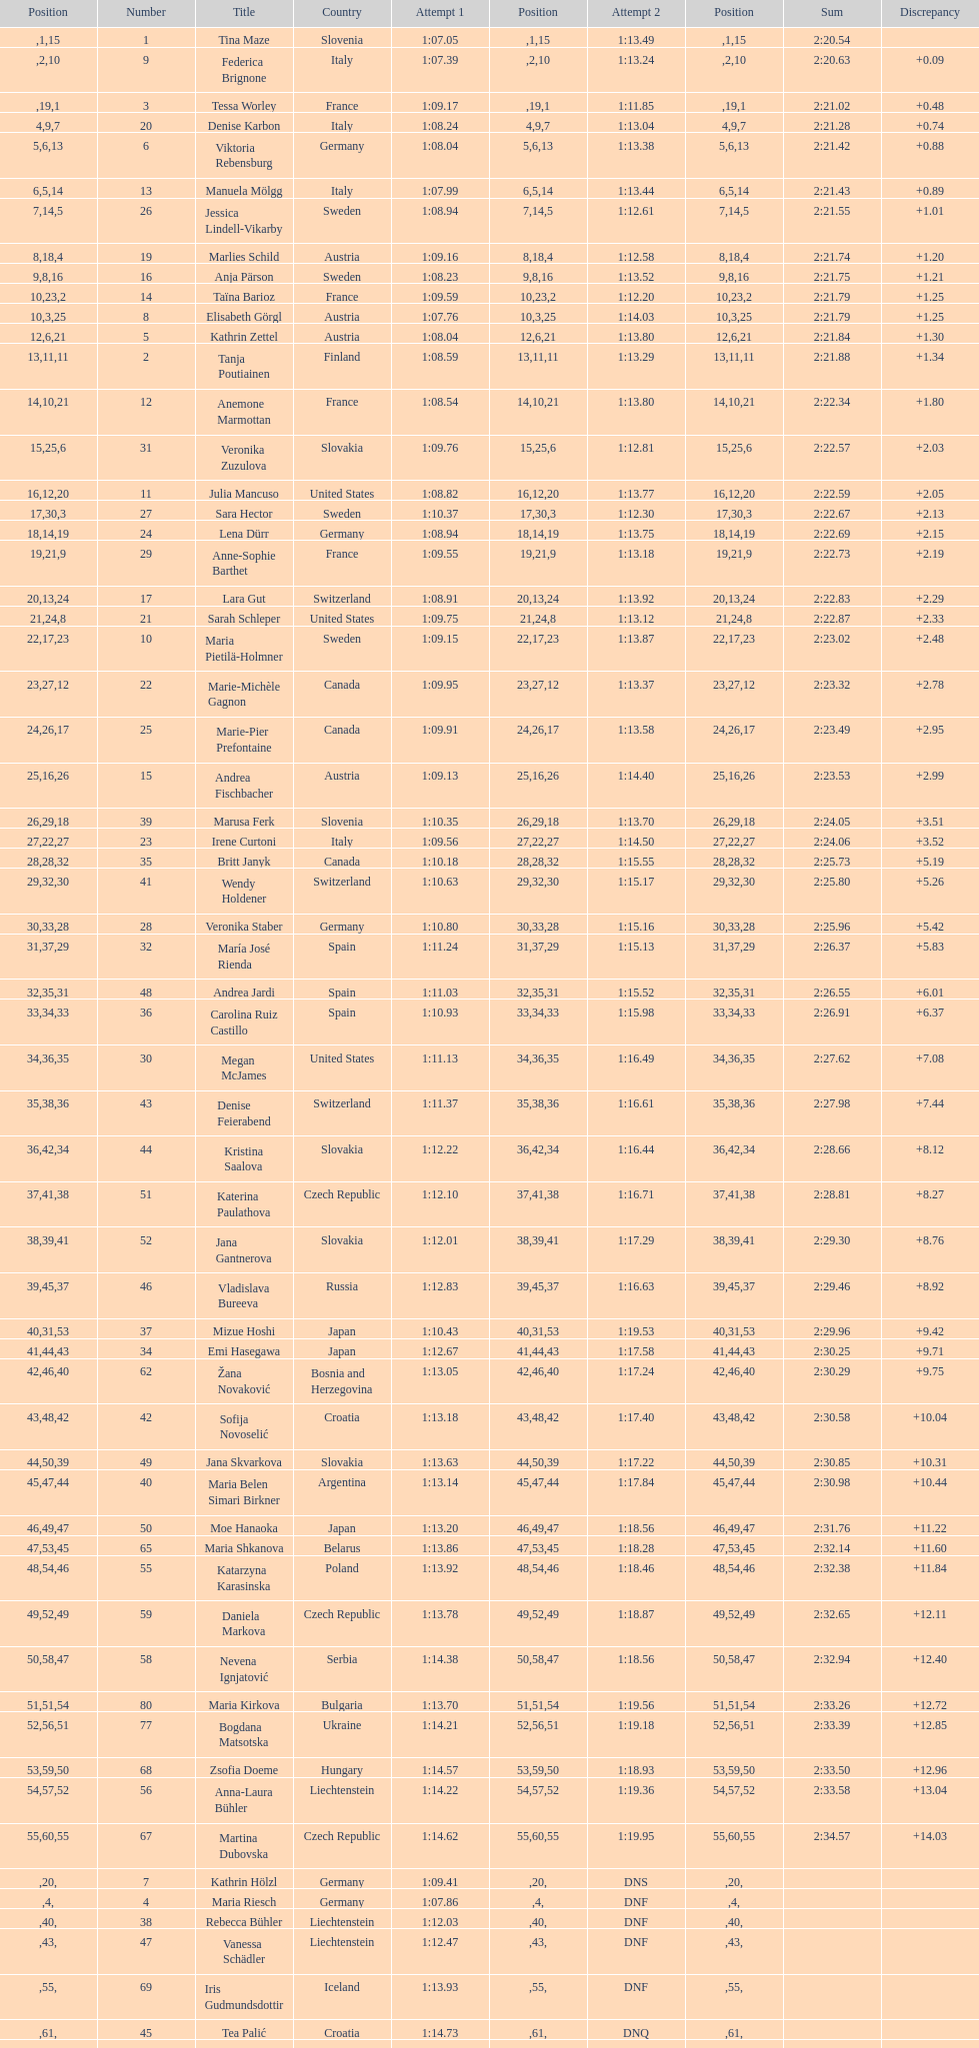What is the last nation to be ranked? Czech Republic. 